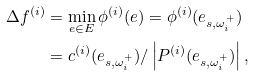<formula> <loc_0><loc_0><loc_500><loc_500>\Delta f ^ { ( i ) } & = \min _ { e \in E } \phi ^ { ( i ) } ( e ) = \phi ^ { ( i ) } ( e _ { s , \omega _ { i } ^ { + } } ) \\ & = c ^ { ( i ) } ( e _ { s , \omega _ { i } ^ { + } } ) / \left | P ^ { ( i ) } ( e _ { s , \omega _ { i } ^ { + } } ) \right | ,</formula> 